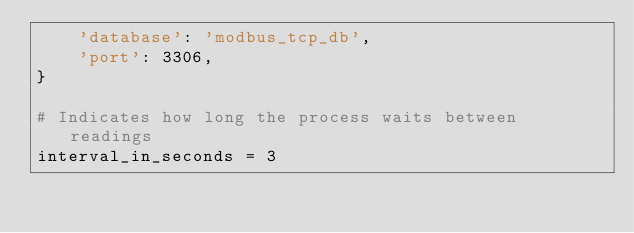Convert code to text. <code><loc_0><loc_0><loc_500><loc_500><_Python_>    'database': 'modbus_tcp_db',
    'port': 3306,
}

# Indicates how long the process waits between readings
interval_in_seconds = 3
</code> 